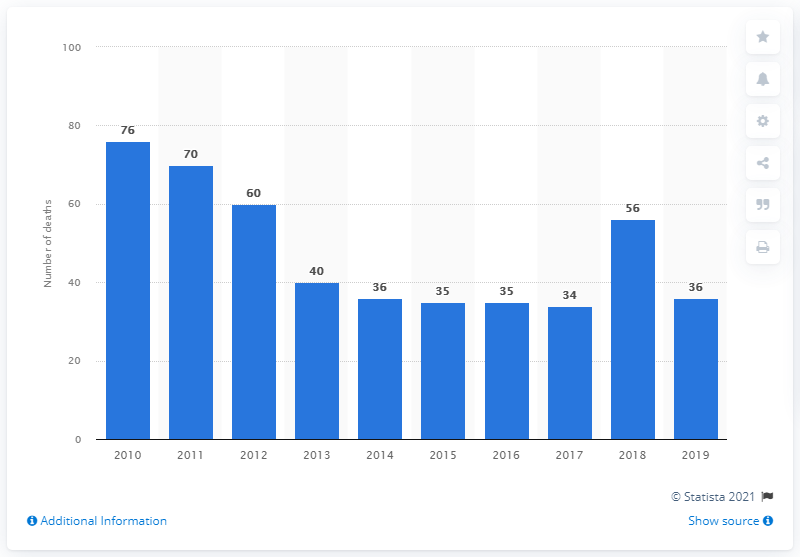Give some essential details in this illustration. In 2010, Brazil reported 76 deaths due to malaria. In 2019, there were 36 reported deaths due to malaria in Brazil. 